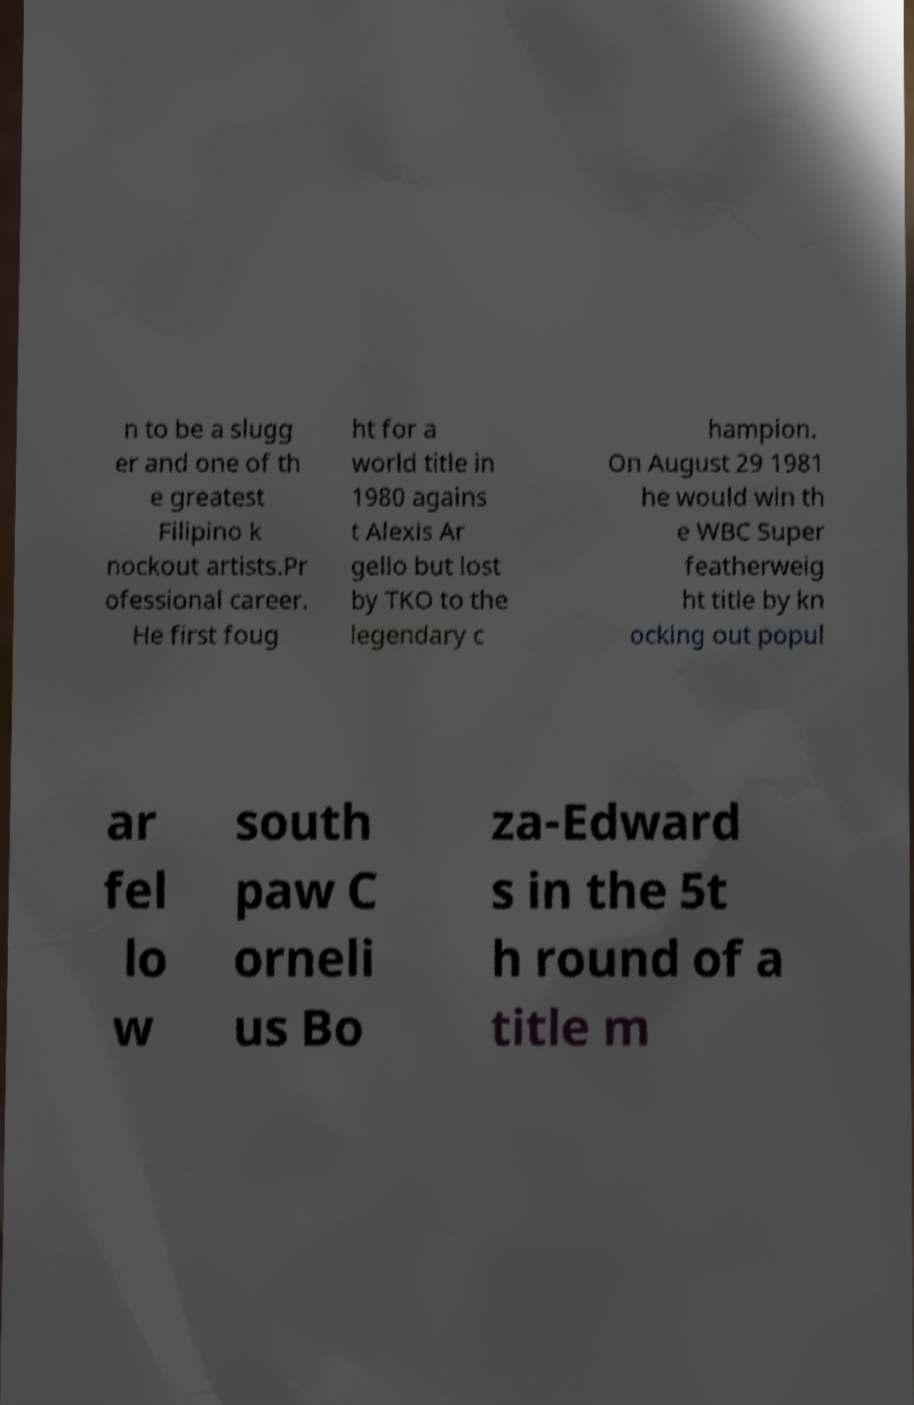Please identify and transcribe the text found in this image. n to be a slugg er and one of th e greatest Filipino k nockout artists.Pr ofessional career. He first foug ht for a world title in 1980 agains t Alexis Ar gello but lost by TKO to the legendary c hampion. On August 29 1981 he would win th e WBC Super featherweig ht title by kn ocking out popul ar fel lo w south paw C orneli us Bo za-Edward s in the 5t h round of a title m 